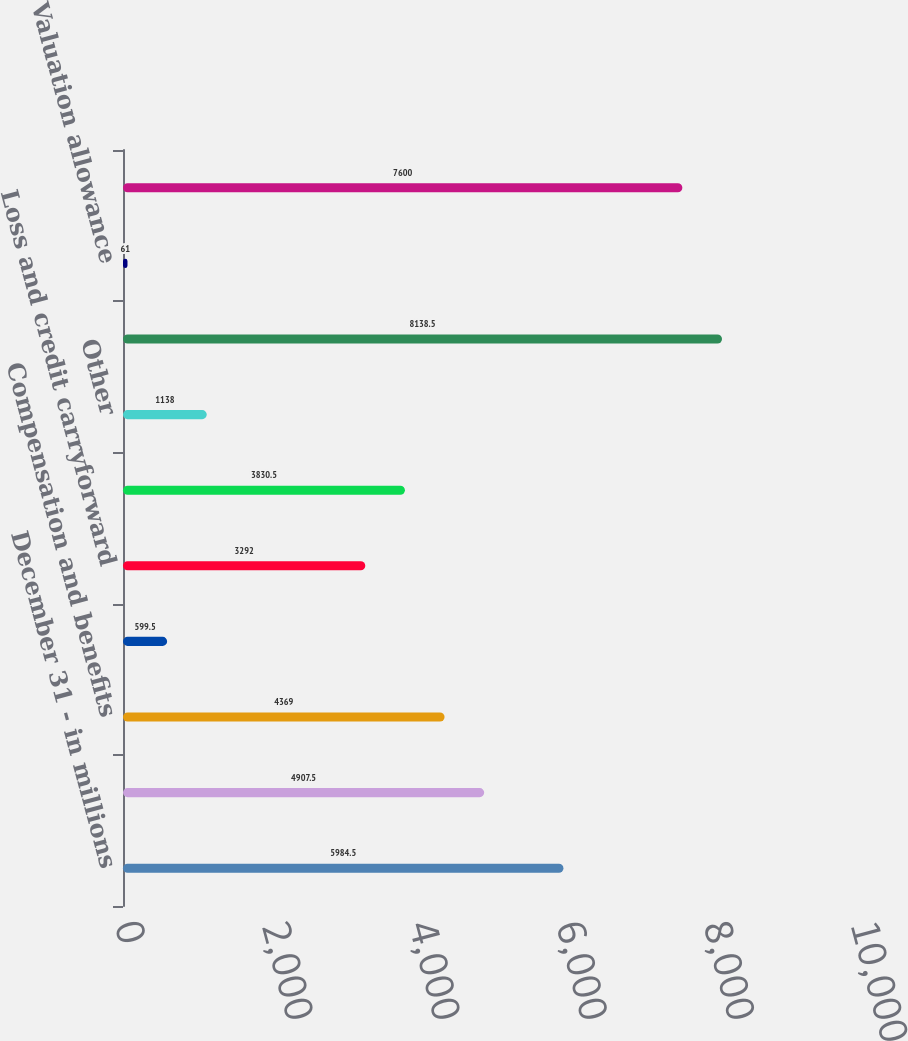Convert chart to OTSL. <chart><loc_0><loc_0><loc_500><loc_500><bar_chart><fcel>December 31 - in millions<fcel>Allowance for loan and lease<fcel>Compensation and benefits<fcel>Partnership investments<fcel>Loss and credit carryforward<fcel>Accrued expenses<fcel>Other<fcel>Total gross deferred tax<fcel>Valuation allowance<fcel>Total deferred tax assets<nl><fcel>5984.5<fcel>4907.5<fcel>4369<fcel>599.5<fcel>3292<fcel>3830.5<fcel>1138<fcel>8138.5<fcel>61<fcel>7600<nl></chart> 